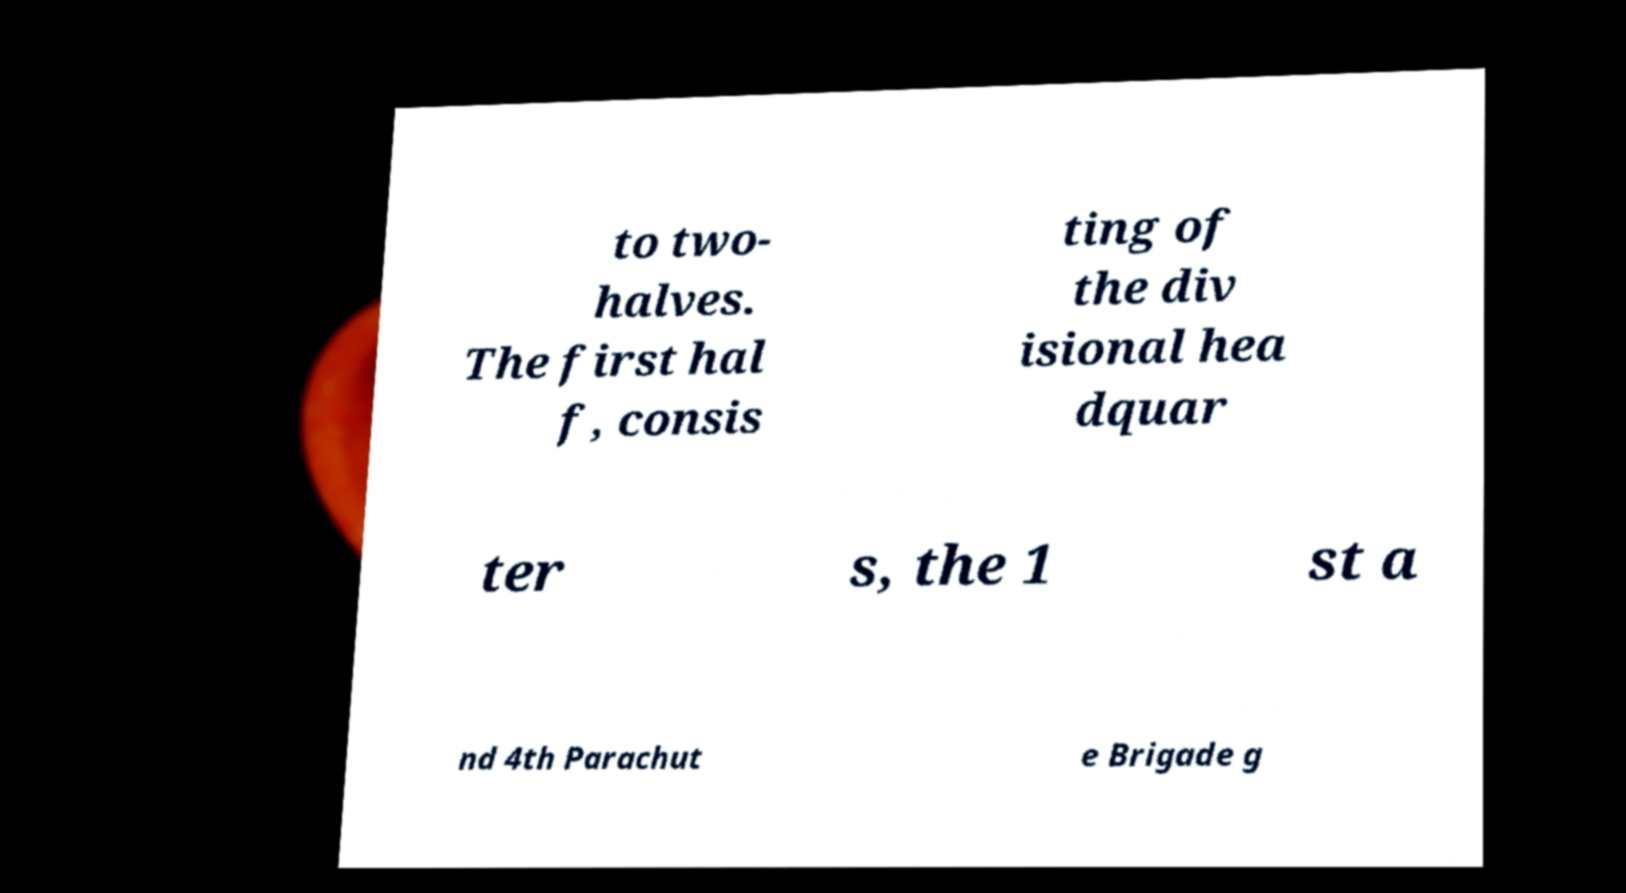Please identify and transcribe the text found in this image. to two- halves. The first hal f, consis ting of the div isional hea dquar ter s, the 1 st a nd 4th Parachut e Brigade g 